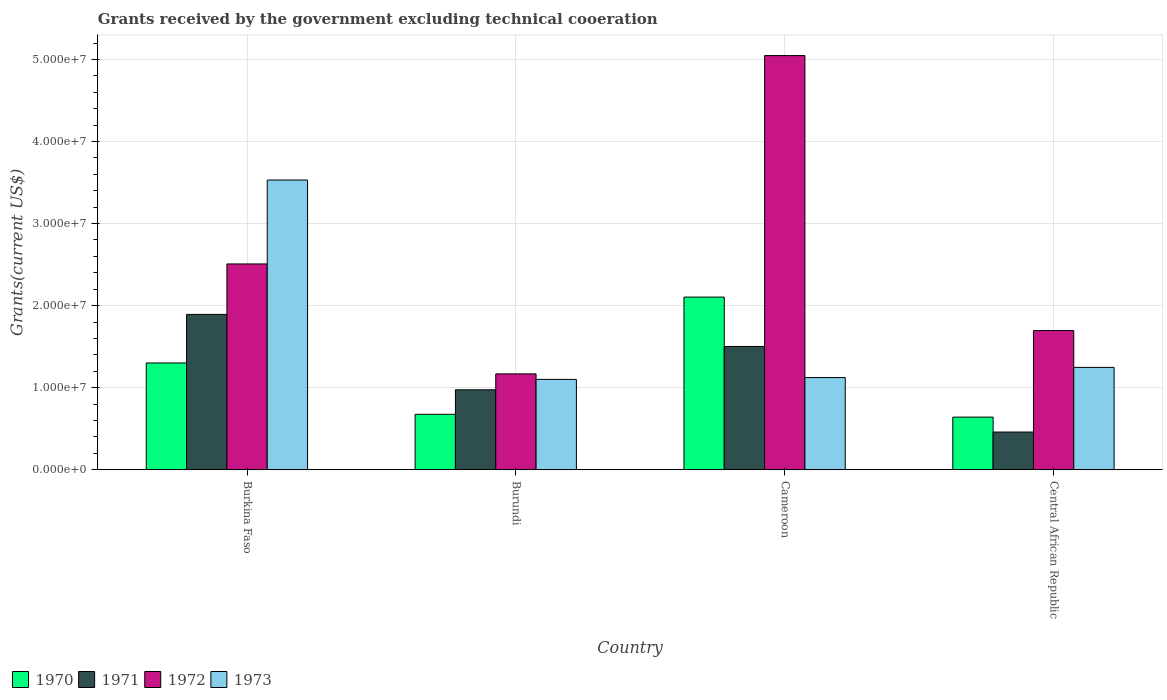Are the number of bars on each tick of the X-axis equal?
Your answer should be very brief. Yes. How many bars are there on the 1st tick from the left?
Ensure brevity in your answer.  4. What is the label of the 1st group of bars from the left?
Provide a short and direct response. Burkina Faso. What is the total grants received by the government in 1972 in Burkina Faso?
Keep it short and to the point. 2.51e+07. Across all countries, what is the maximum total grants received by the government in 1973?
Provide a short and direct response. 3.53e+07. Across all countries, what is the minimum total grants received by the government in 1972?
Your response must be concise. 1.17e+07. In which country was the total grants received by the government in 1973 maximum?
Offer a very short reply. Burkina Faso. In which country was the total grants received by the government in 1973 minimum?
Ensure brevity in your answer.  Burundi. What is the total total grants received by the government in 1973 in the graph?
Give a very brief answer. 7.00e+07. What is the difference between the total grants received by the government in 1973 in Burkina Faso and that in Central African Republic?
Ensure brevity in your answer.  2.28e+07. What is the difference between the total grants received by the government in 1971 in Burkina Faso and the total grants received by the government in 1973 in Cameroon?
Offer a very short reply. 7.70e+06. What is the average total grants received by the government in 1973 per country?
Your answer should be compact. 1.75e+07. What is the difference between the total grants received by the government of/in 1970 and total grants received by the government of/in 1972 in Burkina Faso?
Your answer should be compact. -1.21e+07. What is the ratio of the total grants received by the government in 1973 in Burkina Faso to that in Cameroon?
Offer a terse response. 3.14. Is the difference between the total grants received by the government in 1970 in Burkina Faso and Central African Republic greater than the difference between the total grants received by the government in 1972 in Burkina Faso and Central African Republic?
Offer a terse response. No. What is the difference between the highest and the second highest total grants received by the government in 1971?
Provide a short and direct response. 9.19e+06. What is the difference between the highest and the lowest total grants received by the government in 1972?
Your answer should be compact. 3.88e+07. In how many countries, is the total grants received by the government in 1972 greater than the average total grants received by the government in 1972 taken over all countries?
Keep it short and to the point. 1. How many bars are there?
Provide a succinct answer. 16. How many countries are there in the graph?
Your response must be concise. 4. What is the difference between two consecutive major ticks on the Y-axis?
Provide a succinct answer. 1.00e+07. Does the graph contain any zero values?
Your response must be concise. No. Where does the legend appear in the graph?
Provide a short and direct response. Bottom left. How many legend labels are there?
Give a very brief answer. 4. How are the legend labels stacked?
Provide a short and direct response. Horizontal. What is the title of the graph?
Make the answer very short. Grants received by the government excluding technical cooeration. Does "1964" appear as one of the legend labels in the graph?
Provide a short and direct response. No. What is the label or title of the Y-axis?
Make the answer very short. Grants(current US$). What is the Grants(current US$) in 1970 in Burkina Faso?
Make the answer very short. 1.30e+07. What is the Grants(current US$) of 1971 in Burkina Faso?
Give a very brief answer. 1.89e+07. What is the Grants(current US$) in 1972 in Burkina Faso?
Keep it short and to the point. 2.51e+07. What is the Grants(current US$) of 1973 in Burkina Faso?
Offer a terse response. 3.53e+07. What is the Grants(current US$) of 1970 in Burundi?
Ensure brevity in your answer.  6.75e+06. What is the Grants(current US$) of 1971 in Burundi?
Provide a short and direct response. 9.74e+06. What is the Grants(current US$) in 1972 in Burundi?
Make the answer very short. 1.17e+07. What is the Grants(current US$) of 1973 in Burundi?
Make the answer very short. 1.10e+07. What is the Grants(current US$) in 1970 in Cameroon?
Your answer should be compact. 2.10e+07. What is the Grants(current US$) of 1971 in Cameroon?
Your answer should be very brief. 1.50e+07. What is the Grants(current US$) in 1972 in Cameroon?
Provide a short and direct response. 5.05e+07. What is the Grants(current US$) of 1973 in Cameroon?
Your answer should be very brief. 1.12e+07. What is the Grants(current US$) of 1970 in Central African Republic?
Your response must be concise. 6.41e+06. What is the Grants(current US$) of 1971 in Central African Republic?
Your answer should be compact. 4.59e+06. What is the Grants(current US$) in 1972 in Central African Republic?
Keep it short and to the point. 1.70e+07. What is the Grants(current US$) in 1973 in Central African Republic?
Your answer should be very brief. 1.25e+07. Across all countries, what is the maximum Grants(current US$) of 1970?
Offer a terse response. 2.10e+07. Across all countries, what is the maximum Grants(current US$) in 1971?
Make the answer very short. 1.89e+07. Across all countries, what is the maximum Grants(current US$) of 1972?
Your answer should be compact. 5.05e+07. Across all countries, what is the maximum Grants(current US$) of 1973?
Keep it short and to the point. 3.53e+07. Across all countries, what is the minimum Grants(current US$) of 1970?
Make the answer very short. 6.41e+06. Across all countries, what is the minimum Grants(current US$) of 1971?
Give a very brief answer. 4.59e+06. Across all countries, what is the minimum Grants(current US$) of 1972?
Keep it short and to the point. 1.17e+07. Across all countries, what is the minimum Grants(current US$) in 1973?
Ensure brevity in your answer.  1.10e+07. What is the total Grants(current US$) in 1970 in the graph?
Ensure brevity in your answer.  4.72e+07. What is the total Grants(current US$) in 1971 in the graph?
Provide a succinct answer. 4.83e+07. What is the total Grants(current US$) in 1972 in the graph?
Keep it short and to the point. 1.04e+08. What is the total Grants(current US$) of 1973 in the graph?
Your answer should be very brief. 7.00e+07. What is the difference between the Grants(current US$) in 1970 in Burkina Faso and that in Burundi?
Provide a short and direct response. 6.26e+06. What is the difference between the Grants(current US$) of 1971 in Burkina Faso and that in Burundi?
Your response must be concise. 9.19e+06. What is the difference between the Grants(current US$) in 1972 in Burkina Faso and that in Burundi?
Your answer should be compact. 1.34e+07. What is the difference between the Grants(current US$) in 1973 in Burkina Faso and that in Burundi?
Provide a succinct answer. 2.43e+07. What is the difference between the Grants(current US$) of 1970 in Burkina Faso and that in Cameroon?
Your response must be concise. -8.03e+06. What is the difference between the Grants(current US$) in 1971 in Burkina Faso and that in Cameroon?
Make the answer very short. 3.91e+06. What is the difference between the Grants(current US$) in 1972 in Burkina Faso and that in Cameroon?
Keep it short and to the point. -2.54e+07. What is the difference between the Grants(current US$) in 1973 in Burkina Faso and that in Cameroon?
Provide a short and direct response. 2.41e+07. What is the difference between the Grants(current US$) in 1970 in Burkina Faso and that in Central African Republic?
Your answer should be compact. 6.60e+06. What is the difference between the Grants(current US$) in 1971 in Burkina Faso and that in Central African Republic?
Ensure brevity in your answer.  1.43e+07. What is the difference between the Grants(current US$) of 1972 in Burkina Faso and that in Central African Republic?
Your response must be concise. 8.12e+06. What is the difference between the Grants(current US$) in 1973 in Burkina Faso and that in Central African Republic?
Offer a terse response. 2.28e+07. What is the difference between the Grants(current US$) in 1970 in Burundi and that in Cameroon?
Ensure brevity in your answer.  -1.43e+07. What is the difference between the Grants(current US$) of 1971 in Burundi and that in Cameroon?
Your response must be concise. -5.28e+06. What is the difference between the Grants(current US$) in 1972 in Burundi and that in Cameroon?
Provide a short and direct response. -3.88e+07. What is the difference between the Grants(current US$) in 1973 in Burundi and that in Cameroon?
Give a very brief answer. -2.20e+05. What is the difference between the Grants(current US$) in 1970 in Burundi and that in Central African Republic?
Your response must be concise. 3.40e+05. What is the difference between the Grants(current US$) of 1971 in Burundi and that in Central African Republic?
Your response must be concise. 5.15e+06. What is the difference between the Grants(current US$) of 1972 in Burundi and that in Central African Republic?
Offer a very short reply. -5.28e+06. What is the difference between the Grants(current US$) of 1973 in Burundi and that in Central African Republic?
Keep it short and to the point. -1.46e+06. What is the difference between the Grants(current US$) in 1970 in Cameroon and that in Central African Republic?
Ensure brevity in your answer.  1.46e+07. What is the difference between the Grants(current US$) in 1971 in Cameroon and that in Central African Republic?
Provide a short and direct response. 1.04e+07. What is the difference between the Grants(current US$) in 1972 in Cameroon and that in Central African Republic?
Your answer should be compact. 3.35e+07. What is the difference between the Grants(current US$) in 1973 in Cameroon and that in Central African Republic?
Keep it short and to the point. -1.24e+06. What is the difference between the Grants(current US$) of 1970 in Burkina Faso and the Grants(current US$) of 1971 in Burundi?
Provide a succinct answer. 3.27e+06. What is the difference between the Grants(current US$) of 1970 in Burkina Faso and the Grants(current US$) of 1972 in Burundi?
Your answer should be very brief. 1.33e+06. What is the difference between the Grants(current US$) in 1970 in Burkina Faso and the Grants(current US$) in 1973 in Burundi?
Your answer should be very brief. 2.00e+06. What is the difference between the Grants(current US$) of 1971 in Burkina Faso and the Grants(current US$) of 1972 in Burundi?
Provide a succinct answer. 7.25e+06. What is the difference between the Grants(current US$) in 1971 in Burkina Faso and the Grants(current US$) in 1973 in Burundi?
Make the answer very short. 7.92e+06. What is the difference between the Grants(current US$) of 1972 in Burkina Faso and the Grants(current US$) of 1973 in Burundi?
Provide a succinct answer. 1.41e+07. What is the difference between the Grants(current US$) of 1970 in Burkina Faso and the Grants(current US$) of 1971 in Cameroon?
Offer a terse response. -2.01e+06. What is the difference between the Grants(current US$) of 1970 in Burkina Faso and the Grants(current US$) of 1972 in Cameroon?
Your answer should be very brief. -3.75e+07. What is the difference between the Grants(current US$) in 1970 in Burkina Faso and the Grants(current US$) in 1973 in Cameroon?
Provide a short and direct response. 1.78e+06. What is the difference between the Grants(current US$) of 1971 in Burkina Faso and the Grants(current US$) of 1972 in Cameroon?
Provide a short and direct response. -3.16e+07. What is the difference between the Grants(current US$) of 1971 in Burkina Faso and the Grants(current US$) of 1973 in Cameroon?
Your response must be concise. 7.70e+06. What is the difference between the Grants(current US$) of 1972 in Burkina Faso and the Grants(current US$) of 1973 in Cameroon?
Make the answer very short. 1.38e+07. What is the difference between the Grants(current US$) of 1970 in Burkina Faso and the Grants(current US$) of 1971 in Central African Republic?
Your answer should be very brief. 8.42e+06. What is the difference between the Grants(current US$) in 1970 in Burkina Faso and the Grants(current US$) in 1972 in Central African Republic?
Provide a short and direct response. -3.95e+06. What is the difference between the Grants(current US$) of 1970 in Burkina Faso and the Grants(current US$) of 1973 in Central African Republic?
Your answer should be very brief. 5.40e+05. What is the difference between the Grants(current US$) of 1971 in Burkina Faso and the Grants(current US$) of 1972 in Central African Republic?
Make the answer very short. 1.97e+06. What is the difference between the Grants(current US$) in 1971 in Burkina Faso and the Grants(current US$) in 1973 in Central African Republic?
Your response must be concise. 6.46e+06. What is the difference between the Grants(current US$) of 1972 in Burkina Faso and the Grants(current US$) of 1973 in Central African Republic?
Your answer should be very brief. 1.26e+07. What is the difference between the Grants(current US$) of 1970 in Burundi and the Grants(current US$) of 1971 in Cameroon?
Ensure brevity in your answer.  -8.27e+06. What is the difference between the Grants(current US$) in 1970 in Burundi and the Grants(current US$) in 1972 in Cameroon?
Give a very brief answer. -4.37e+07. What is the difference between the Grants(current US$) of 1970 in Burundi and the Grants(current US$) of 1973 in Cameroon?
Ensure brevity in your answer.  -4.48e+06. What is the difference between the Grants(current US$) of 1971 in Burundi and the Grants(current US$) of 1972 in Cameroon?
Offer a terse response. -4.07e+07. What is the difference between the Grants(current US$) in 1971 in Burundi and the Grants(current US$) in 1973 in Cameroon?
Your answer should be compact. -1.49e+06. What is the difference between the Grants(current US$) in 1970 in Burundi and the Grants(current US$) in 1971 in Central African Republic?
Provide a short and direct response. 2.16e+06. What is the difference between the Grants(current US$) in 1970 in Burundi and the Grants(current US$) in 1972 in Central African Republic?
Provide a succinct answer. -1.02e+07. What is the difference between the Grants(current US$) in 1970 in Burundi and the Grants(current US$) in 1973 in Central African Republic?
Your answer should be compact. -5.72e+06. What is the difference between the Grants(current US$) in 1971 in Burundi and the Grants(current US$) in 1972 in Central African Republic?
Your answer should be very brief. -7.22e+06. What is the difference between the Grants(current US$) in 1971 in Burundi and the Grants(current US$) in 1973 in Central African Republic?
Your answer should be compact. -2.73e+06. What is the difference between the Grants(current US$) of 1972 in Burundi and the Grants(current US$) of 1973 in Central African Republic?
Offer a terse response. -7.90e+05. What is the difference between the Grants(current US$) in 1970 in Cameroon and the Grants(current US$) in 1971 in Central African Republic?
Keep it short and to the point. 1.64e+07. What is the difference between the Grants(current US$) of 1970 in Cameroon and the Grants(current US$) of 1972 in Central African Republic?
Keep it short and to the point. 4.08e+06. What is the difference between the Grants(current US$) in 1970 in Cameroon and the Grants(current US$) in 1973 in Central African Republic?
Keep it short and to the point. 8.57e+06. What is the difference between the Grants(current US$) of 1971 in Cameroon and the Grants(current US$) of 1972 in Central African Republic?
Keep it short and to the point. -1.94e+06. What is the difference between the Grants(current US$) of 1971 in Cameroon and the Grants(current US$) of 1973 in Central African Republic?
Offer a very short reply. 2.55e+06. What is the difference between the Grants(current US$) in 1972 in Cameroon and the Grants(current US$) in 1973 in Central African Republic?
Keep it short and to the point. 3.80e+07. What is the average Grants(current US$) in 1970 per country?
Make the answer very short. 1.18e+07. What is the average Grants(current US$) of 1971 per country?
Your answer should be very brief. 1.21e+07. What is the average Grants(current US$) in 1972 per country?
Offer a terse response. 2.60e+07. What is the average Grants(current US$) of 1973 per country?
Make the answer very short. 1.75e+07. What is the difference between the Grants(current US$) of 1970 and Grants(current US$) of 1971 in Burkina Faso?
Your response must be concise. -5.92e+06. What is the difference between the Grants(current US$) in 1970 and Grants(current US$) in 1972 in Burkina Faso?
Ensure brevity in your answer.  -1.21e+07. What is the difference between the Grants(current US$) of 1970 and Grants(current US$) of 1973 in Burkina Faso?
Make the answer very short. -2.23e+07. What is the difference between the Grants(current US$) in 1971 and Grants(current US$) in 1972 in Burkina Faso?
Offer a terse response. -6.15e+06. What is the difference between the Grants(current US$) in 1971 and Grants(current US$) in 1973 in Burkina Faso?
Your answer should be compact. -1.64e+07. What is the difference between the Grants(current US$) of 1972 and Grants(current US$) of 1973 in Burkina Faso?
Give a very brief answer. -1.02e+07. What is the difference between the Grants(current US$) of 1970 and Grants(current US$) of 1971 in Burundi?
Provide a succinct answer. -2.99e+06. What is the difference between the Grants(current US$) of 1970 and Grants(current US$) of 1972 in Burundi?
Keep it short and to the point. -4.93e+06. What is the difference between the Grants(current US$) of 1970 and Grants(current US$) of 1973 in Burundi?
Your response must be concise. -4.26e+06. What is the difference between the Grants(current US$) in 1971 and Grants(current US$) in 1972 in Burundi?
Provide a short and direct response. -1.94e+06. What is the difference between the Grants(current US$) in 1971 and Grants(current US$) in 1973 in Burundi?
Your answer should be compact. -1.27e+06. What is the difference between the Grants(current US$) of 1972 and Grants(current US$) of 1973 in Burundi?
Make the answer very short. 6.70e+05. What is the difference between the Grants(current US$) in 1970 and Grants(current US$) in 1971 in Cameroon?
Keep it short and to the point. 6.02e+06. What is the difference between the Grants(current US$) of 1970 and Grants(current US$) of 1972 in Cameroon?
Make the answer very short. -2.94e+07. What is the difference between the Grants(current US$) of 1970 and Grants(current US$) of 1973 in Cameroon?
Provide a short and direct response. 9.81e+06. What is the difference between the Grants(current US$) of 1971 and Grants(current US$) of 1972 in Cameroon?
Offer a terse response. -3.55e+07. What is the difference between the Grants(current US$) of 1971 and Grants(current US$) of 1973 in Cameroon?
Your answer should be very brief. 3.79e+06. What is the difference between the Grants(current US$) of 1972 and Grants(current US$) of 1973 in Cameroon?
Make the answer very short. 3.92e+07. What is the difference between the Grants(current US$) in 1970 and Grants(current US$) in 1971 in Central African Republic?
Provide a short and direct response. 1.82e+06. What is the difference between the Grants(current US$) in 1970 and Grants(current US$) in 1972 in Central African Republic?
Keep it short and to the point. -1.06e+07. What is the difference between the Grants(current US$) of 1970 and Grants(current US$) of 1973 in Central African Republic?
Offer a terse response. -6.06e+06. What is the difference between the Grants(current US$) in 1971 and Grants(current US$) in 1972 in Central African Republic?
Keep it short and to the point. -1.24e+07. What is the difference between the Grants(current US$) in 1971 and Grants(current US$) in 1973 in Central African Republic?
Make the answer very short. -7.88e+06. What is the difference between the Grants(current US$) of 1972 and Grants(current US$) of 1973 in Central African Republic?
Provide a short and direct response. 4.49e+06. What is the ratio of the Grants(current US$) of 1970 in Burkina Faso to that in Burundi?
Ensure brevity in your answer.  1.93. What is the ratio of the Grants(current US$) of 1971 in Burkina Faso to that in Burundi?
Ensure brevity in your answer.  1.94. What is the ratio of the Grants(current US$) in 1972 in Burkina Faso to that in Burundi?
Your answer should be compact. 2.15. What is the ratio of the Grants(current US$) in 1973 in Burkina Faso to that in Burundi?
Make the answer very short. 3.21. What is the ratio of the Grants(current US$) in 1970 in Burkina Faso to that in Cameroon?
Your answer should be compact. 0.62. What is the ratio of the Grants(current US$) in 1971 in Burkina Faso to that in Cameroon?
Keep it short and to the point. 1.26. What is the ratio of the Grants(current US$) in 1972 in Burkina Faso to that in Cameroon?
Make the answer very short. 0.5. What is the ratio of the Grants(current US$) of 1973 in Burkina Faso to that in Cameroon?
Provide a succinct answer. 3.14. What is the ratio of the Grants(current US$) in 1970 in Burkina Faso to that in Central African Republic?
Your answer should be very brief. 2.03. What is the ratio of the Grants(current US$) in 1971 in Burkina Faso to that in Central African Republic?
Make the answer very short. 4.12. What is the ratio of the Grants(current US$) in 1972 in Burkina Faso to that in Central African Republic?
Provide a short and direct response. 1.48. What is the ratio of the Grants(current US$) in 1973 in Burkina Faso to that in Central African Republic?
Give a very brief answer. 2.83. What is the ratio of the Grants(current US$) in 1970 in Burundi to that in Cameroon?
Your response must be concise. 0.32. What is the ratio of the Grants(current US$) of 1971 in Burundi to that in Cameroon?
Your answer should be compact. 0.65. What is the ratio of the Grants(current US$) of 1972 in Burundi to that in Cameroon?
Ensure brevity in your answer.  0.23. What is the ratio of the Grants(current US$) of 1973 in Burundi to that in Cameroon?
Your answer should be very brief. 0.98. What is the ratio of the Grants(current US$) of 1970 in Burundi to that in Central African Republic?
Keep it short and to the point. 1.05. What is the ratio of the Grants(current US$) in 1971 in Burundi to that in Central African Republic?
Provide a succinct answer. 2.12. What is the ratio of the Grants(current US$) in 1972 in Burundi to that in Central African Republic?
Make the answer very short. 0.69. What is the ratio of the Grants(current US$) in 1973 in Burundi to that in Central African Republic?
Your answer should be very brief. 0.88. What is the ratio of the Grants(current US$) of 1970 in Cameroon to that in Central African Republic?
Offer a very short reply. 3.28. What is the ratio of the Grants(current US$) in 1971 in Cameroon to that in Central African Republic?
Keep it short and to the point. 3.27. What is the ratio of the Grants(current US$) of 1972 in Cameroon to that in Central African Republic?
Provide a succinct answer. 2.98. What is the ratio of the Grants(current US$) of 1973 in Cameroon to that in Central African Republic?
Your answer should be very brief. 0.9. What is the difference between the highest and the second highest Grants(current US$) in 1970?
Give a very brief answer. 8.03e+06. What is the difference between the highest and the second highest Grants(current US$) in 1971?
Your answer should be very brief. 3.91e+06. What is the difference between the highest and the second highest Grants(current US$) in 1972?
Your answer should be compact. 2.54e+07. What is the difference between the highest and the second highest Grants(current US$) of 1973?
Make the answer very short. 2.28e+07. What is the difference between the highest and the lowest Grants(current US$) in 1970?
Offer a very short reply. 1.46e+07. What is the difference between the highest and the lowest Grants(current US$) in 1971?
Ensure brevity in your answer.  1.43e+07. What is the difference between the highest and the lowest Grants(current US$) of 1972?
Ensure brevity in your answer.  3.88e+07. What is the difference between the highest and the lowest Grants(current US$) in 1973?
Make the answer very short. 2.43e+07. 